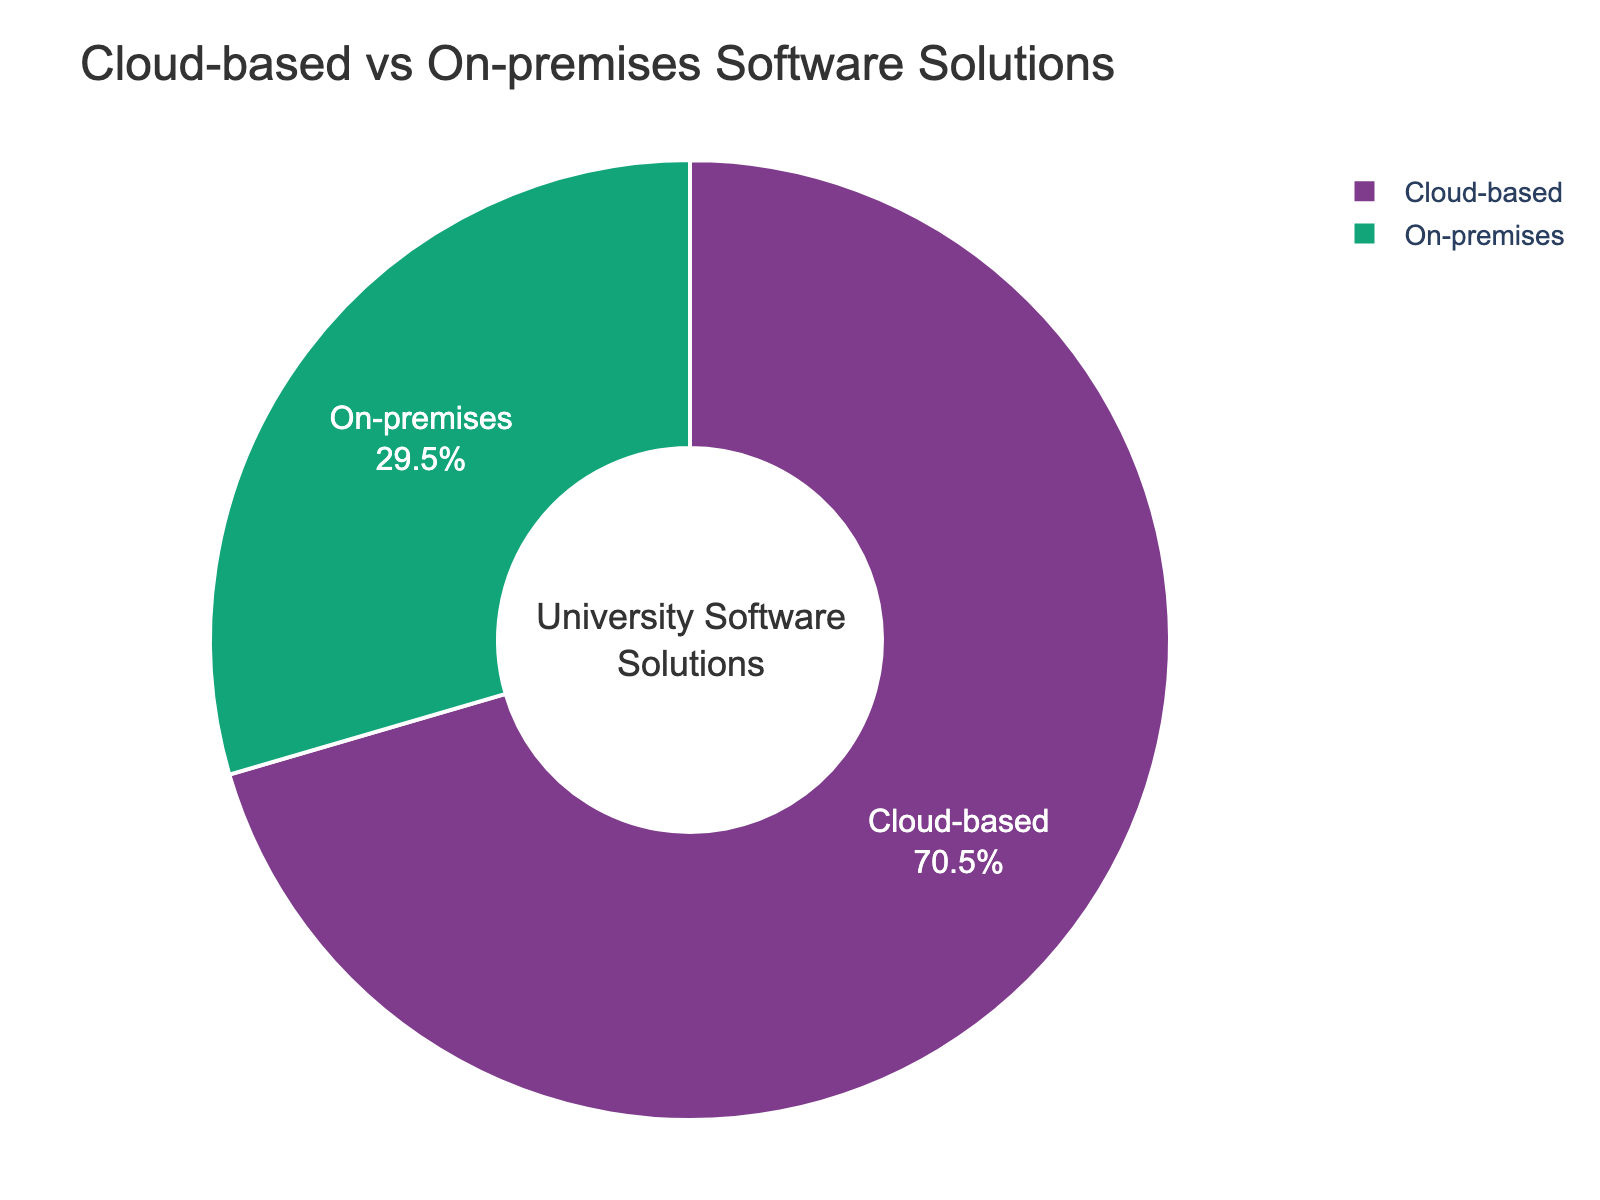How many more percentage points do cloud-based solutions have compared to on-premises solutions? First, note the total percentage of cloud-based solutions (68%) and on-premises solutions (32%). Calculate the difference: 68% - 32% = 36 percentage points.
Answer: 36 percentage points What is the percentage breakdown between cloud-based and on-premises solutions? The chart shows two segments. Cloud-based solutions account for 68%, while on-premises solutions account for 32%.
Answer: Cloud-based: 68%, On-premises: 32% Which type of solution is more dominant, cloud-based or on-premises? The chart indicates that the cloud-based segment occupies a larger portion of the pie chart compared to the on-premises segment. Specifically, cloud-based solutions constitute 68% versus 32% for on-premises.
Answer: Cloud-based If we were to combine AWS, Azure, and Google Cloud, what percentage of the total would they represent? AWS, Azure, and Google Cloud are all cloud-based solutions. From the data, AWS is 28%, Azure is 22%, and Google Cloud is 12%. Sum these values: 28% + 22% + 12% = 62%.
Answer: 62% What visual element indicates the proportion of each solution type in the chart? The proportion is indicated by the size of each segment in the pie chart. The larger the segment, the greater the proportion of that solution type.
Answer: Segment size If the on-premises proportion increased by 10 percentage points, what would the new proportions be for both solution types? Start with current proportions: Cloud-based (68%) and On-premises (32%). Increase the on-premises proportion by 10%: 32% + 10% = 42%. Subtract 10% from the cloud-based proportion, as the total must be 100%: 68% - 10% = 58%. New proportions: Cloud-based is 58%, On-premises is 42%.
Answer: Cloud-based: 58%, On-premises: 42% Is there a significant difference between on-premises and cloud-based solutions in this chart? Yes, the difference is significant. Cloud-based solutions make up 68%, while on-premises make up 32%, showing a 36 percentage point difference which is more than double.
Answer: Yes How does the proportion of the largest cloud-based solution compare to the entire on-premises solutions proportion? The largest cloud-based solution is AWS at 28%. The entire on-premises solutions proportion is 32%. 28% is slightly smaller than 32%, showing that AWS alone constitutes nearly the entire on-premises proportion.
Answer: AWS: 28%, On-premises: 32% If on-premises solutions need to make up at least 40% to reach a specific threshold, how many more percentage points do they need? Current on-premises proportion is 32%. To reach 40%, calculate the difference: 40% - 32% = 8 percentage points.
Answer: 8 percentage points 